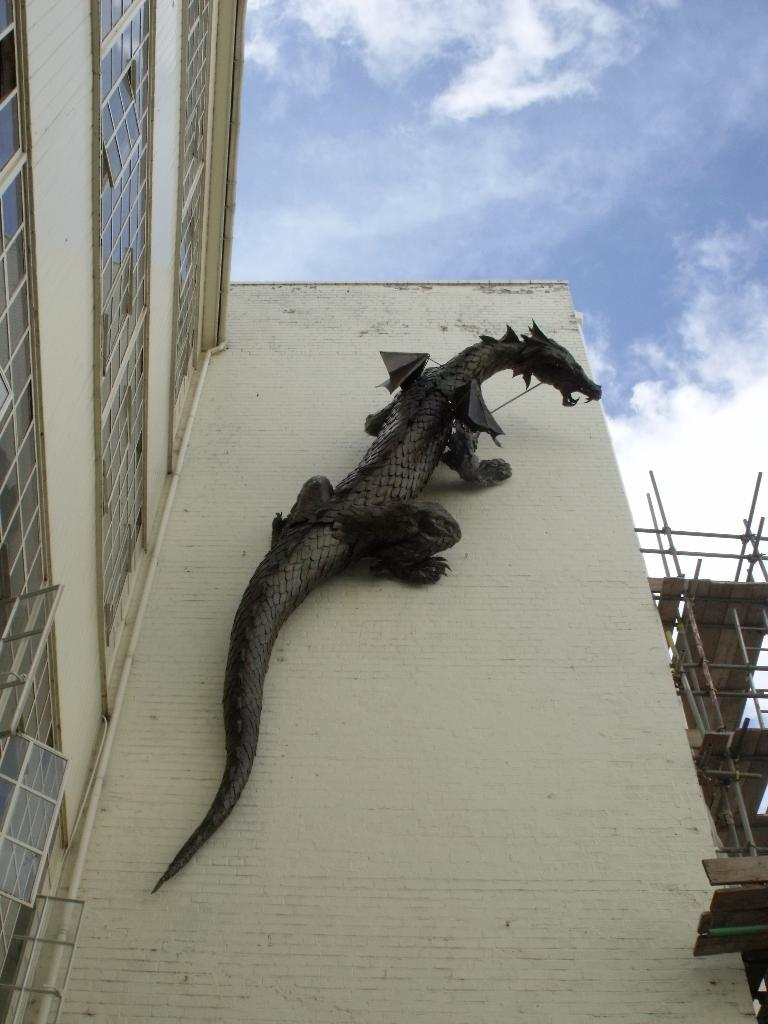What can be seen on the building in the image? There is a replica of an animal on a building in the image. What is happening on the right side of the image? There is an under-construction building on the right side of the image. How would you describe the sky in the image? The sky is blue and cloudy in the image. Can you tell me how many decisions were made at the airport in the image? There is no airport present in the image, so it is not possible to determine how many decisions were made there. What type of steam can be seen coming from the under-construction building? There is no steam visible in the image; it features a replica of an animal on a building, an under-construction building, and a blue and cloudy sky. 